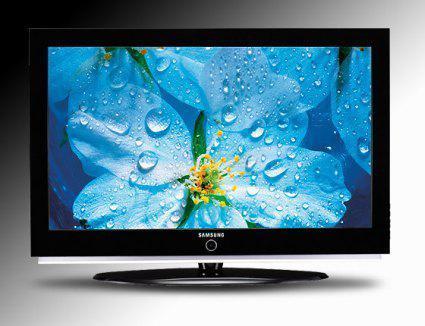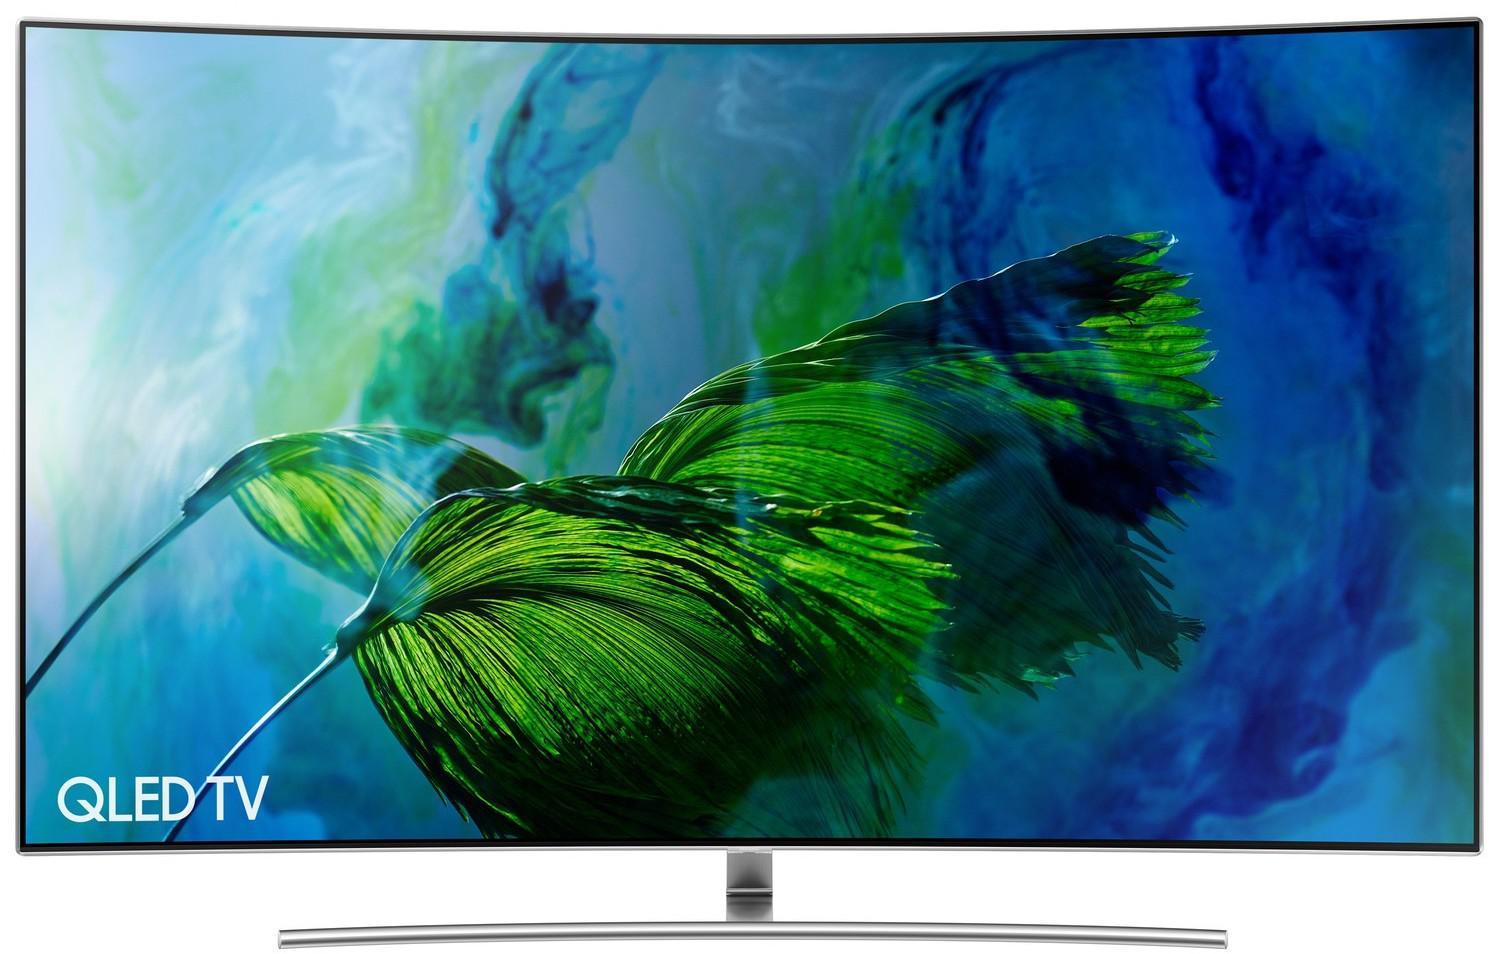The first image is the image on the left, the second image is the image on the right. Assess this claim about the two images: "One of the images features a television displaying a hummingbird next to a flower.". Correct or not? Answer yes or no. No. The first image is the image on the left, the second image is the image on the right. Evaluate the accuracy of this statement regarding the images: "In at least one image there is a television with a blue flower and a single hummingbird drinking from it.". Is it true? Answer yes or no. No. 